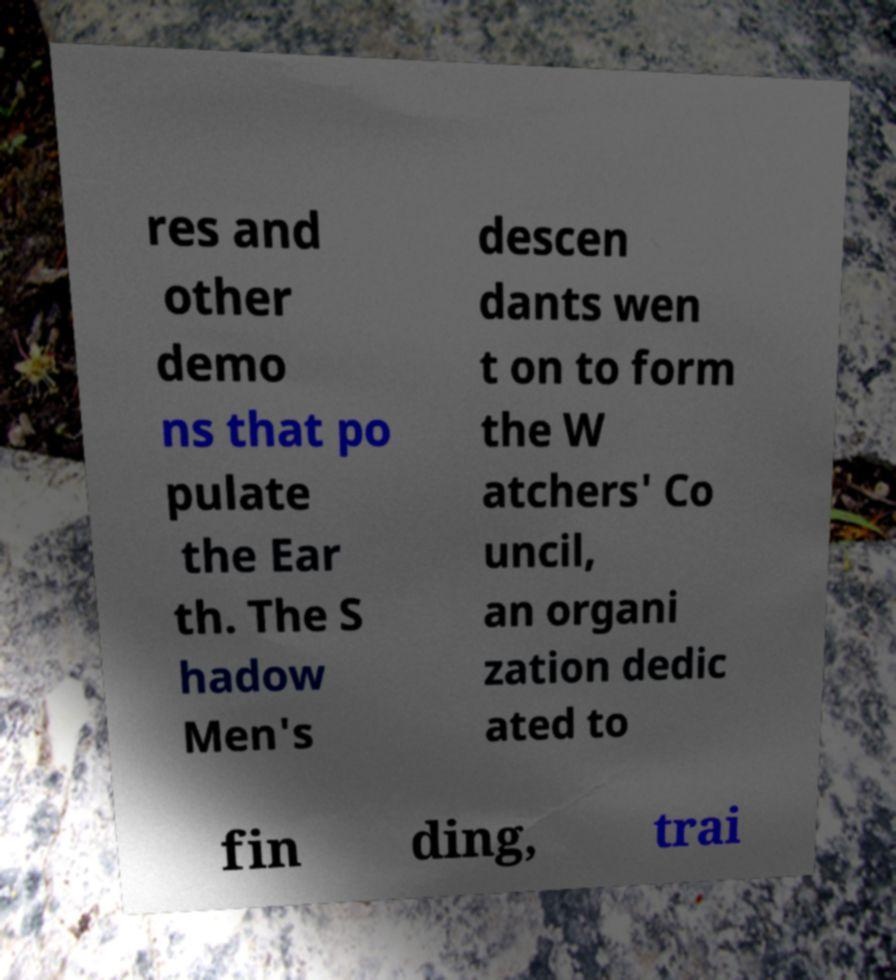Could you extract and type out the text from this image? res and other demo ns that po pulate the Ear th. The S hadow Men's descen dants wen t on to form the W atchers' Co uncil, an organi zation dedic ated to fin ding, trai 